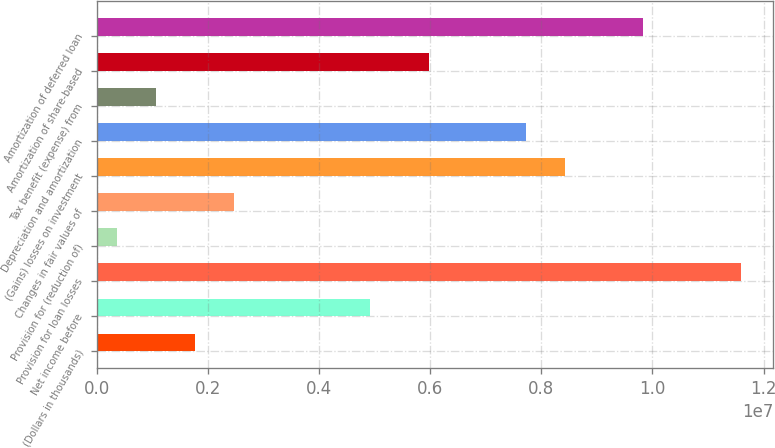<chart> <loc_0><loc_0><loc_500><loc_500><bar_chart><fcel>(Dollars in thousands)<fcel>Net income before<fcel>Provision for loan losses<fcel>Provision for (reduction of)<fcel>Changes in fair values of<fcel>(Gains) losses on investment<fcel>Depreciation and amortization<fcel>Tax benefit (expense) from<fcel>Amortization of share-based<fcel>Amortization of deferred loan<nl><fcel>1.75666e+06<fcel>4.91781e+06<fcel>1.15914e+07<fcel>351698<fcel>2.45913e+06<fcel>8.43021e+06<fcel>7.72773e+06<fcel>1.05418e+06<fcel>5.97153e+06<fcel>9.83516e+06<nl></chart> 